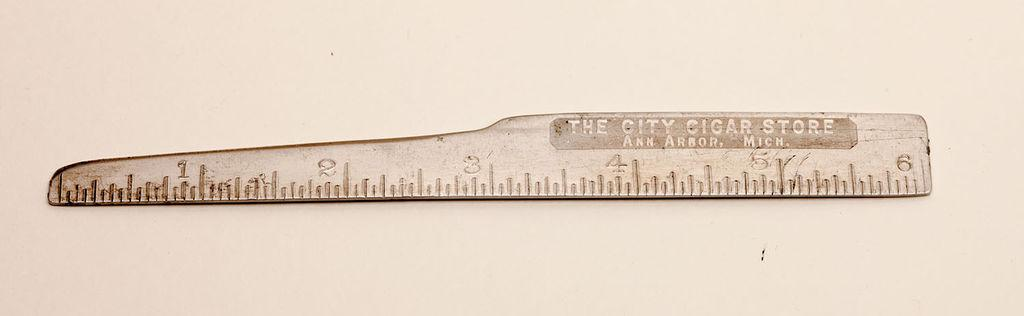Provide a one-sentence caption for the provided image. A ruler that says the City Cigar Store on it. 